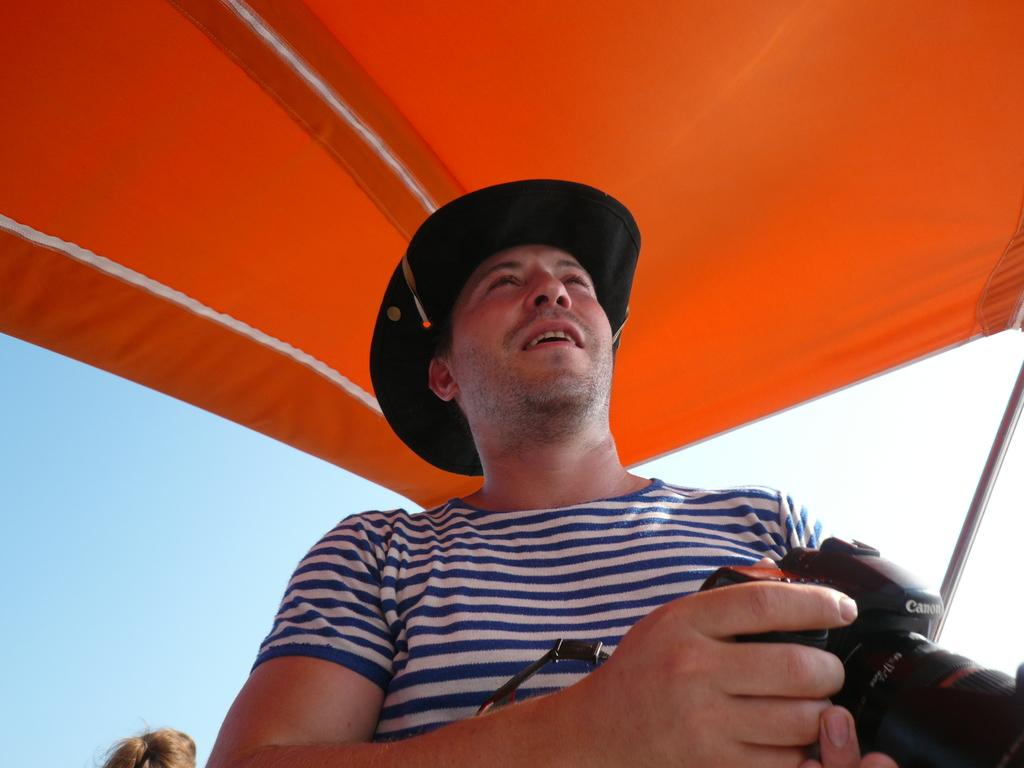Who is present in the image? There is a man in the image. What is the man holding in his hand? The man is holding a camera in his hand. What structure can be seen in the image? There is a tent in the image. What type of song is the man singing in the image? There is no indication in the image that the man is singing a song, so it cannot be determined from the picture. 